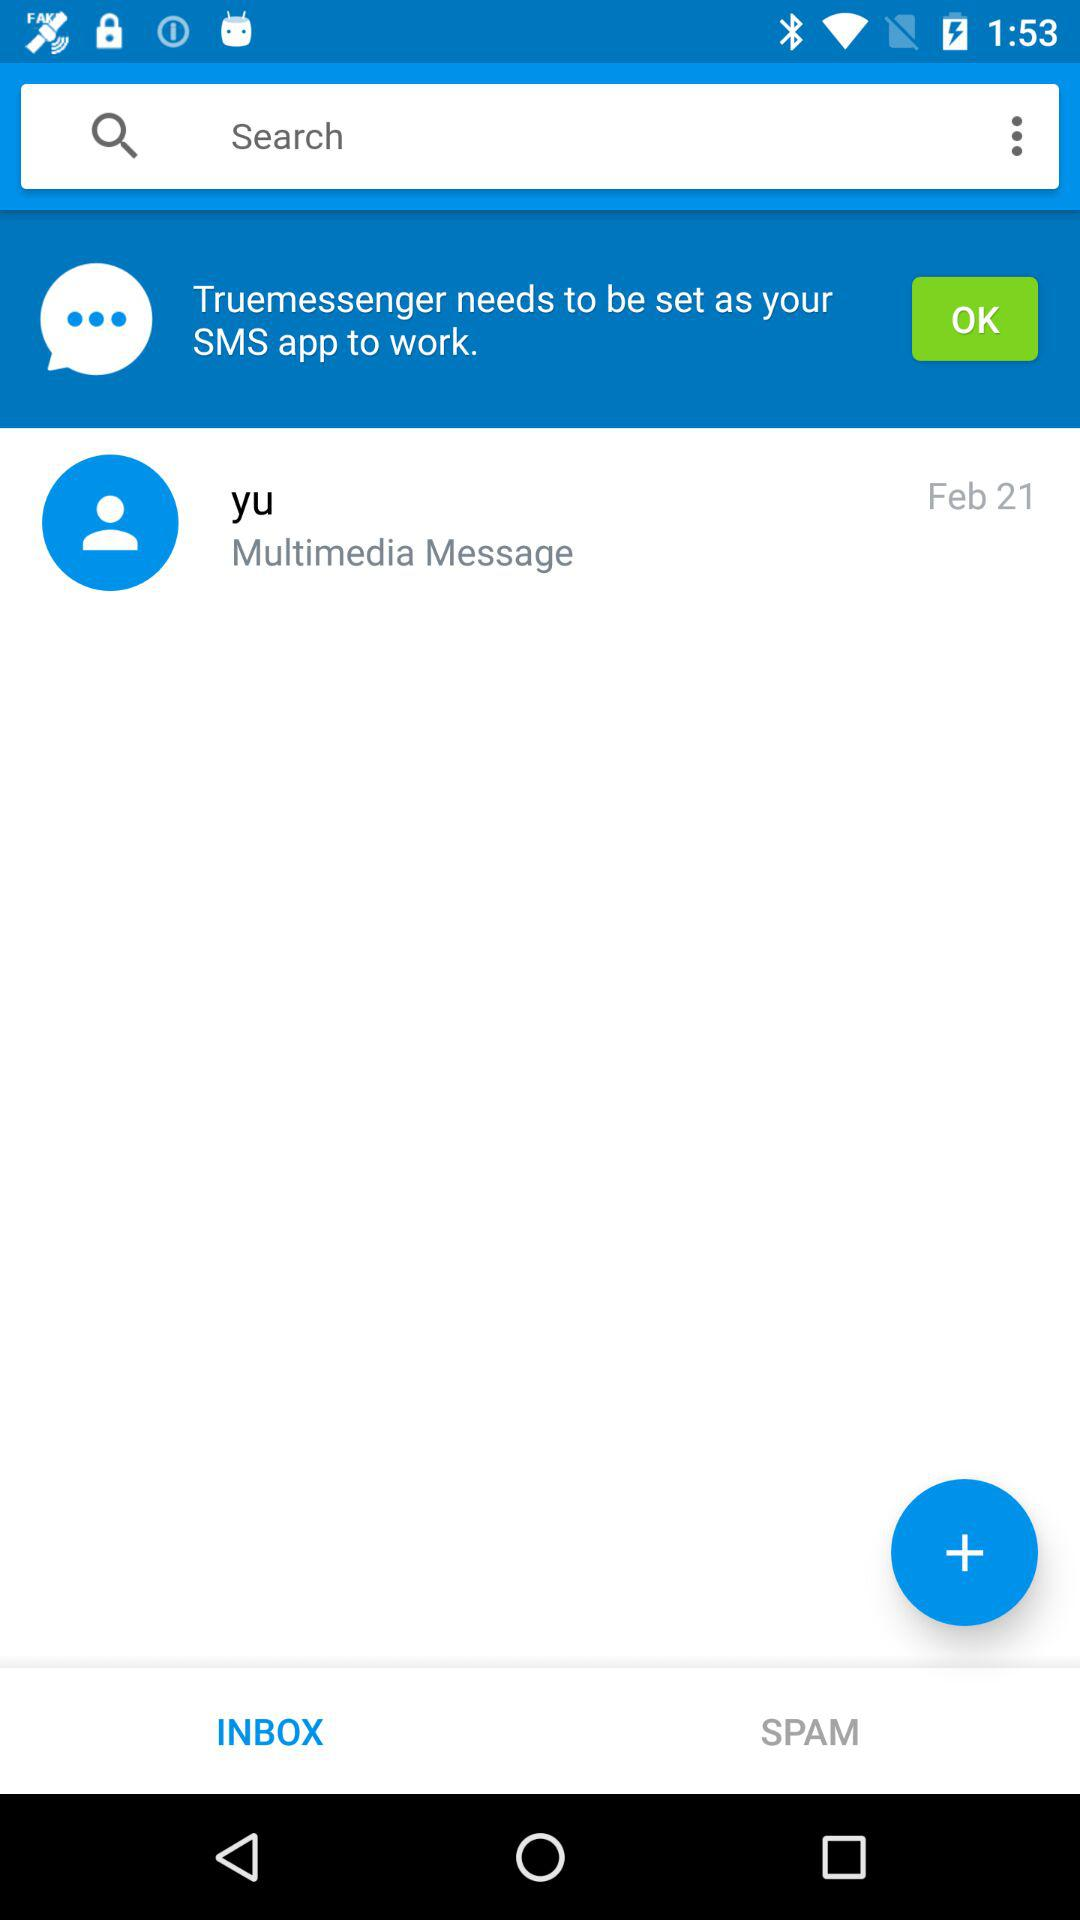On what date was the message received from yu? The message was received on February 21. 